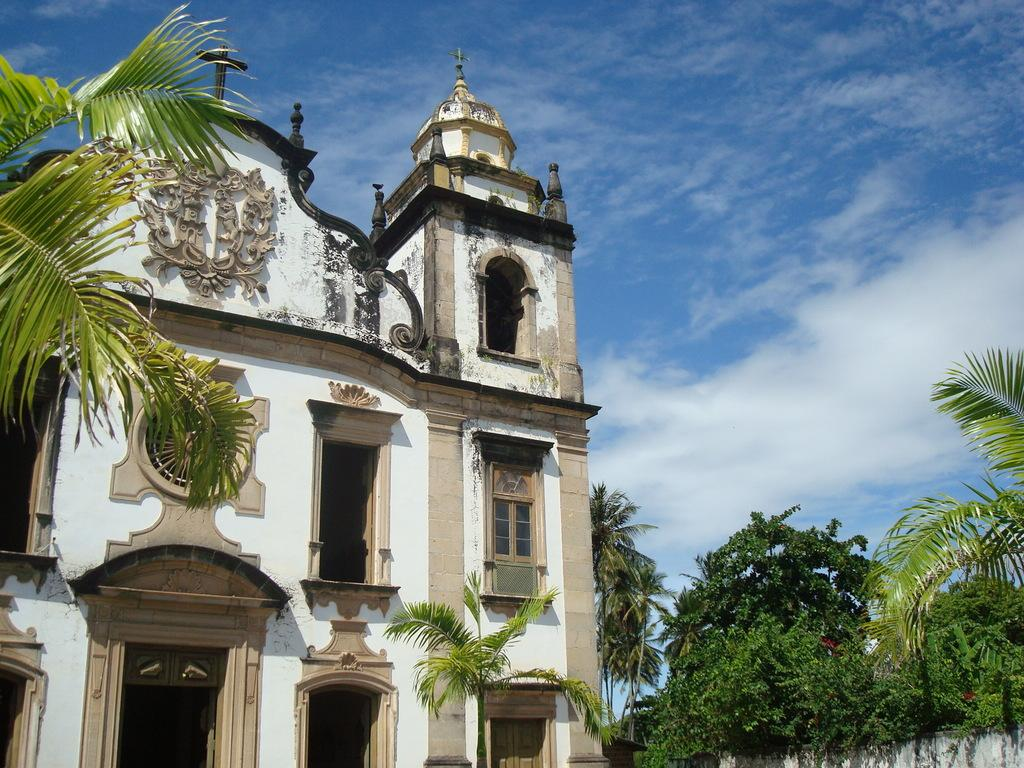What type of structure is visible in the picture? There is a building in the picture. What other natural elements can be seen in the picture? There are trees in the picture. How would you describe the sky in the picture? The sky is blue and cloudy in the picture. What type of meat can be seen hanging from the trees in the picture? There is no meat visible in the picture; it only features a building, trees, and a blue, cloudy sky. 